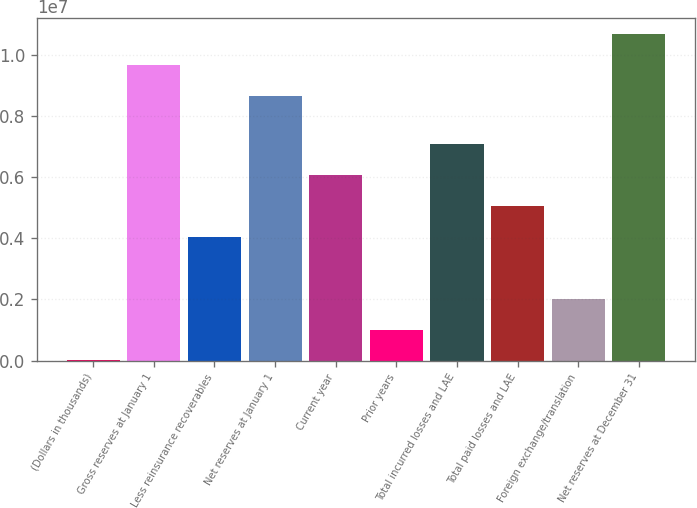<chart> <loc_0><loc_0><loc_500><loc_500><bar_chart><fcel>(Dollars in thousands)<fcel>Gross reserves at January 1<fcel>Less reinsurance recoverables<fcel>Net reserves at January 1<fcel>Current year<fcel>Prior years<fcel>Total incurred losses and LAE<fcel>Total paid losses and LAE<fcel>Foreign exchange/translation<fcel>Net reserves at December 31<nl><fcel>2011<fcel>9.66286e+06<fcel>4.05049e+06<fcel>8.65074e+06<fcel>6.07473e+06<fcel>1.01413e+06<fcel>7.08685e+06<fcel>5.06261e+06<fcel>2.02625e+06<fcel>1.0675e+07<nl></chart> 